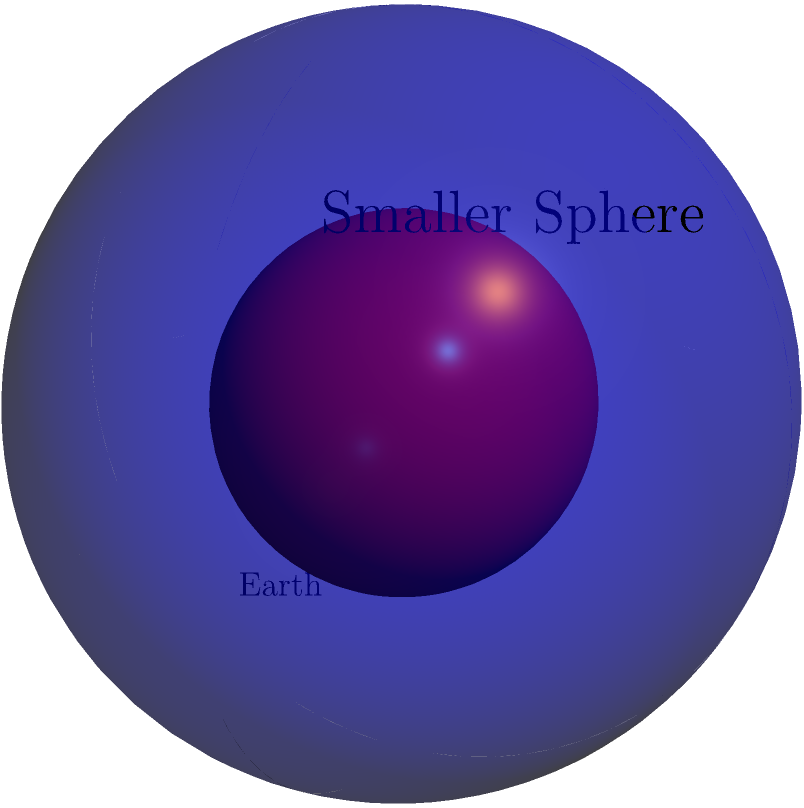The volume of a sphere is given by the formula $V = \frac{4}{3}\pi r^3$, where $r$ is the radius. If the Earth's radius is approximately 6,371 km, and we have a smaller sphere with half the radius of Earth, what percentage of Earth's volume does this smaller sphere occupy? How might this relate to the alleged "expanding Earth" theory some use to challenge mainstream climate science? Let's approach this step-by-step:

1) First, let's calculate the volume of Earth:
   $V_E = \frac{4}{3}\pi (6371)^3 \approx 1.08 \times 10^{12}$ km³

2) Now, let's calculate the volume of the smaller sphere with half the radius:
   $V_S = \frac{4}{3}\pi (3185.5)^3 \approx 1.35 \times 10^{11}$ km³

3) To find what percentage the smaller sphere is of Earth's volume:
   Percentage = $\frac{V_S}{V_E} \times 100\% = \frac{1.35 \times 10^{11}}{1.08 \times 10^{12}} \times 100\% \approx 12.5\%$

4) We can also derive this directly from the ratio of the radii:
   $(\frac{1}{2})^3 = \frac{1}{8} = 0.125 = 12.5\%$

This demonstrates that halving the radius results in a volume that's only 12.5% of the original, not 50% as some might intuitively guess. This exponential relationship between radius and volume is crucial in understanding Earth systems.

Regarding the "expanding Earth" theory: Some who challenge mainstream climate science propose that the Earth is expanding, rather than experiencing climate change. However, this calculation shows how sensitive volume is to changes in radius. Even a small expansion in Earth's radius would result in a significant volume increase, which would be easily detectable by modern scientific instruments. The lack of such observations further supports the robustness of current climate change models over alternative theories.
Answer: 12.5% of Earth's volume 